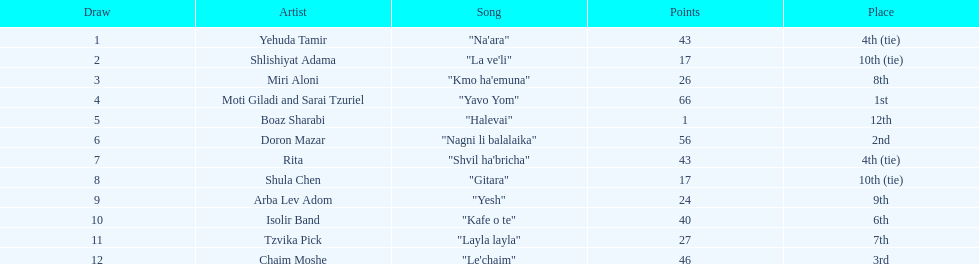How often has an artist secured the top position? 1. Can you give me this table as a dict? {'header': ['Draw', 'Artist', 'Song', 'Points', 'Place'], 'rows': [['1', 'Yehuda Tamir', '"Na\'ara"', '43', '4th (tie)'], ['2', 'Shlishiyat Adama', '"La ve\'li"', '17', '10th (tie)'], ['3', 'Miri Aloni', '"Kmo ha\'emuna"', '26', '8th'], ['4', 'Moti Giladi and Sarai Tzuriel', '"Yavo Yom"', '66', '1st'], ['5', 'Boaz Sharabi', '"Halevai"', '1', '12th'], ['6', 'Doron Mazar', '"Nagni li balalaika"', '56', '2nd'], ['7', 'Rita', '"Shvil ha\'bricha"', '43', '4th (tie)'], ['8', 'Shula Chen', '"Gitara"', '17', '10th (tie)'], ['9', 'Arba Lev Adom', '"Yesh"', '24', '9th'], ['10', 'Isolir Band', '"Kafe o te"', '40', '6th'], ['11', 'Tzvika Pick', '"Layla layla"', '27', '7th'], ['12', 'Chaim Moshe', '"Le\'chaim"', '46', '3rd']]} 